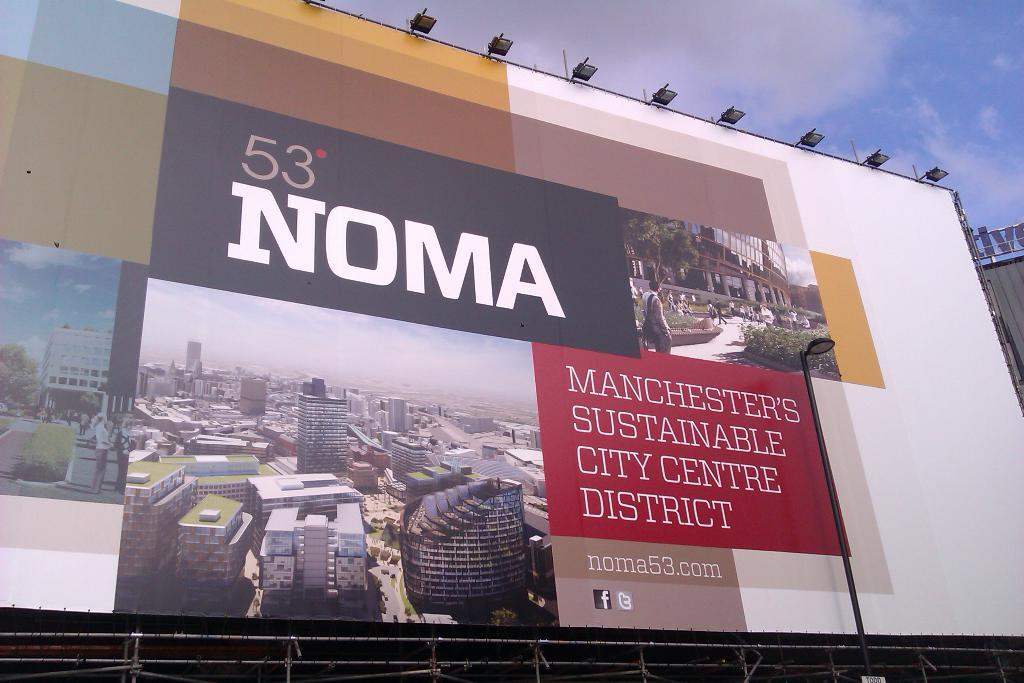Provide a one-sentence caption for the provided image. A large sign located outdoors advertising a new district named  "53 Noma". 